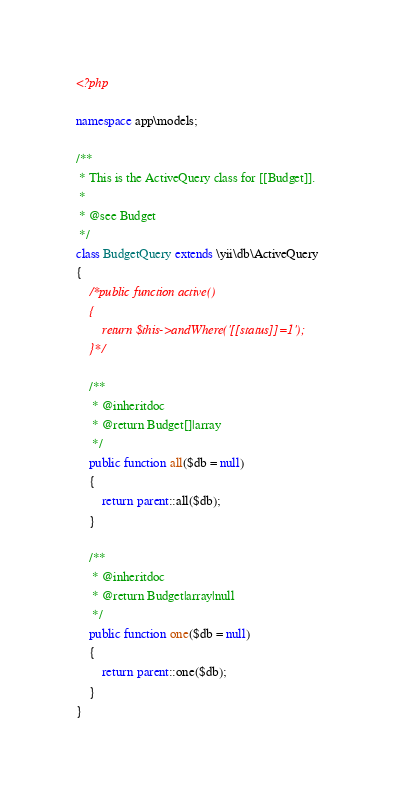Convert code to text. <code><loc_0><loc_0><loc_500><loc_500><_PHP_><?php

namespace app\models;

/**
 * This is the ActiveQuery class for [[Budget]].
 *
 * @see Budget
 */
class BudgetQuery extends \yii\db\ActiveQuery
{
    /*public function active()
    {
        return $this->andWhere('[[status]]=1');
    }*/

    /**
     * @inheritdoc
     * @return Budget[]|array
     */
    public function all($db = null)
    {
        return parent::all($db);
    }

    /**
     * @inheritdoc
     * @return Budget|array|null
     */
    public function one($db = null)
    {
        return parent::one($db);
    }
}
</code> 